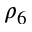<formula> <loc_0><loc_0><loc_500><loc_500>\rho _ { 6 }</formula> 